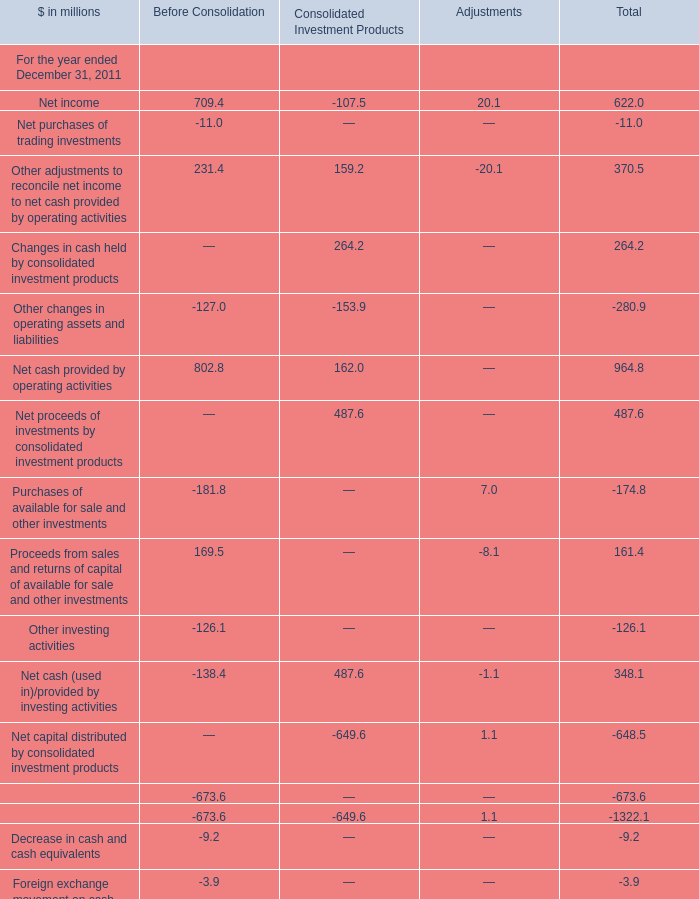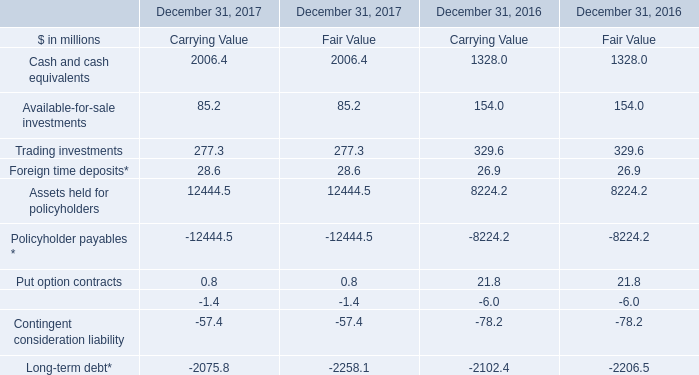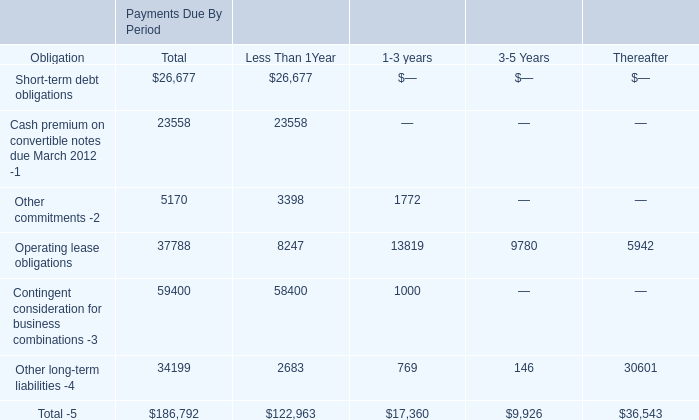What is the column number of the section for which Net cash provided by operating activities is smaller than 100 million? 
Answer: 3. 